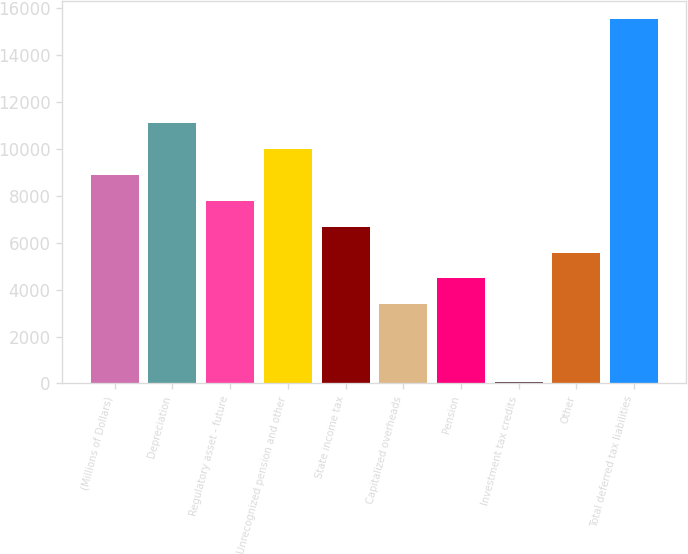<chart> <loc_0><loc_0><loc_500><loc_500><bar_chart><fcel>(Millions of Dollars)<fcel>Depreciation<fcel>Regulatory asset - future<fcel>Unrecognized pension and other<fcel>State income tax<fcel>Capitalized overheads<fcel>Pension<fcel>Investment tax credits<fcel>Other<fcel>Total deferred tax liabilities<nl><fcel>8901.4<fcel>11113<fcel>7795.6<fcel>10007.2<fcel>6689.8<fcel>3372.4<fcel>4478.2<fcel>55<fcel>5584<fcel>15536.2<nl></chart> 